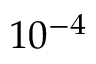<formula> <loc_0><loc_0><loc_500><loc_500>1 0 ^ { - 4 }</formula> 